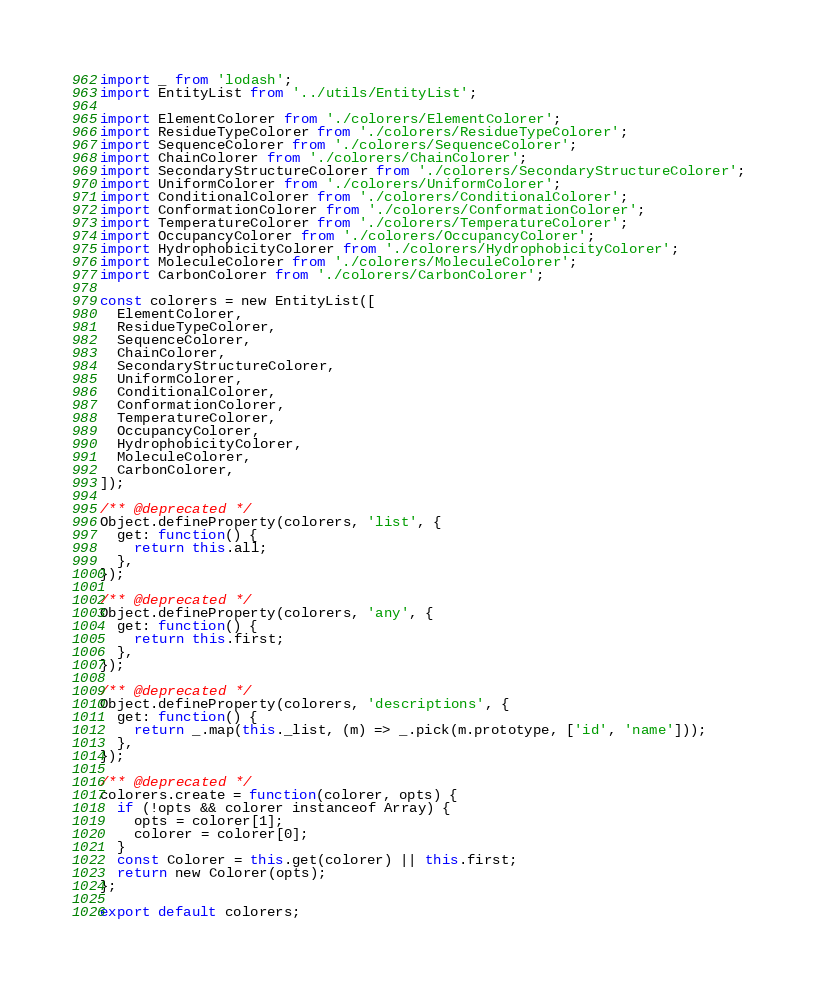<code> <loc_0><loc_0><loc_500><loc_500><_JavaScript_>import _ from 'lodash';
import EntityList from '../utils/EntityList';

import ElementColorer from './colorers/ElementColorer';
import ResidueTypeColorer from './colorers/ResidueTypeColorer';
import SequenceColorer from './colorers/SequenceColorer';
import ChainColorer from './colorers/ChainColorer';
import SecondaryStructureColorer from './colorers/SecondaryStructureColorer';
import UniformColorer from './colorers/UniformColorer';
import ConditionalColorer from './colorers/ConditionalColorer';
import ConformationColorer from './colorers/ConformationColorer';
import TemperatureColorer from './colorers/TemperatureColorer';
import OccupancyColorer from './colorers/OccupancyColorer';
import HydrophobicityColorer from './colorers/HydrophobicityColorer';
import MoleculeColorer from './colorers/MoleculeColorer';
import CarbonColorer from './colorers/CarbonColorer';

const colorers = new EntityList([
  ElementColorer,
  ResidueTypeColorer,
  SequenceColorer,
  ChainColorer,
  SecondaryStructureColorer,
  UniformColorer,
  ConditionalColorer,
  ConformationColorer,
  TemperatureColorer,
  OccupancyColorer,
  HydrophobicityColorer,
  MoleculeColorer,
  CarbonColorer,
]);

/** @deprecated */
Object.defineProperty(colorers, 'list', {
  get: function() {
    return this.all;
  },
});

/** @deprecated */
Object.defineProperty(colorers, 'any', {
  get: function() {
    return this.first;
  },
});

/** @deprecated */
Object.defineProperty(colorers, 'descriptions', {
  get: function() {
    return _.map(this._list, (m) => _.pick(m.prototype, ['id', 'name']));
  },
});

/** @deprecated */
colorers.create = function(colorer, opts) {
  if (!opts && colorer instanceof Array) {
    opts = colorer[1];
    colorer = colorer[0];
  }
  const Colorer = this.get(colorer) || this.first;
  return new Colorer(opts);
};

export default colorers;
</code> 